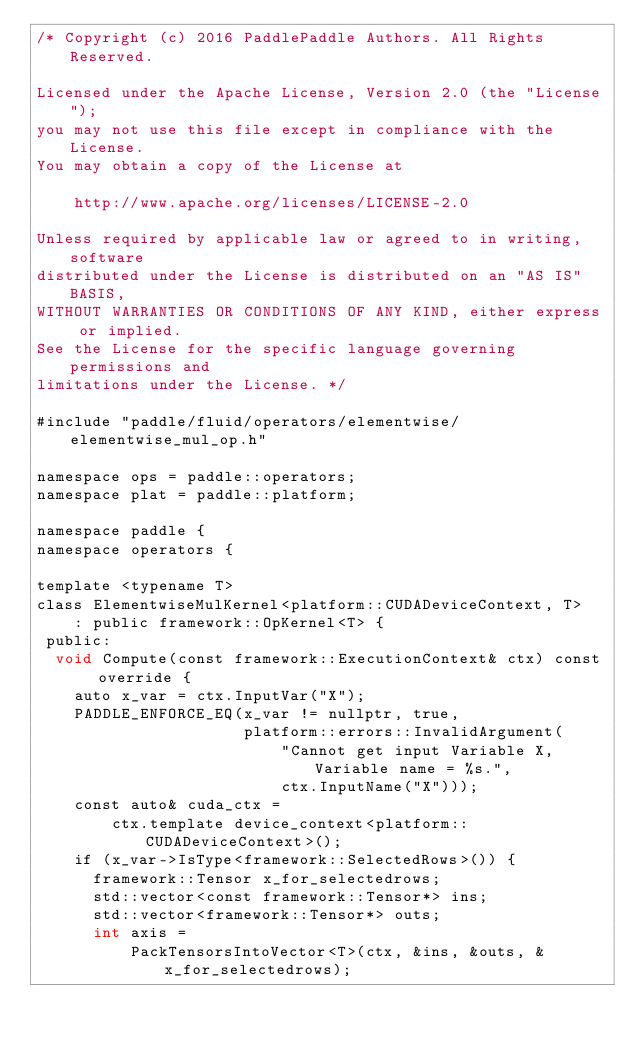Convert code to text. <code><loc_0><loc_0><loc_500><loc_500><_Cuda_>/* Copyright (c) 2016 PaddlePaddle Authors. All Rights Reserved.

Licensed under the Apache License, Version 2.0 (the "License");
you may not use this file except in compliance with the License.
You may obtain a copy of the License at

    http://www.apache.org/licenses/LICENSE-2.0

Unless required by applicable law or agreed to in writing, software
distributed under the License is distributed on an "AS IS" BASIS,
WITHOUT WARRANTIES OR CONDITIONS OF ANY KIND, either express or implied.
See the License for the specific language governing permissions and
limitations under the License. */

#include "paddle/fluid/operators/elementwise/elementwise_mul_op.h"

namespace ops = paddle::operators;
namespace plat = paddle::platform;

namespace paddle {
namespace operators {

template <typename T>
class ElementwiseMulKernel<platform::CUDADeviceContext, T>
    : public framework::OpKernel<T> {
 public:
  void Compute(const framework::ExecutionContext& ctx) const override {
    auto x_var = ctx.InputVar("X");
    PADDLE_ENFORCE_EQ(x_var != nullptr, true,
                      platform::errors::InvalidArgument(
                          "Cannot get input Variable X, Variable name = %s.",
                          ctx.InputName("X")));
    const auto& cuda_ctx =
        ctx.template device_context<platform::CUDADeviceContext>();
    if (x_var->IsType<framework::SelectedRows>()) {
      framework::Tensor x_for_selectedrows;
      std::vector<const framework::Tensor*> ins;
      std::vector<framework::Tensor*> outs;
      int axis =
          PackTensorsIntoVector<T>(ctx, &ins, &outs, &x_for_selectedrows);</code> 